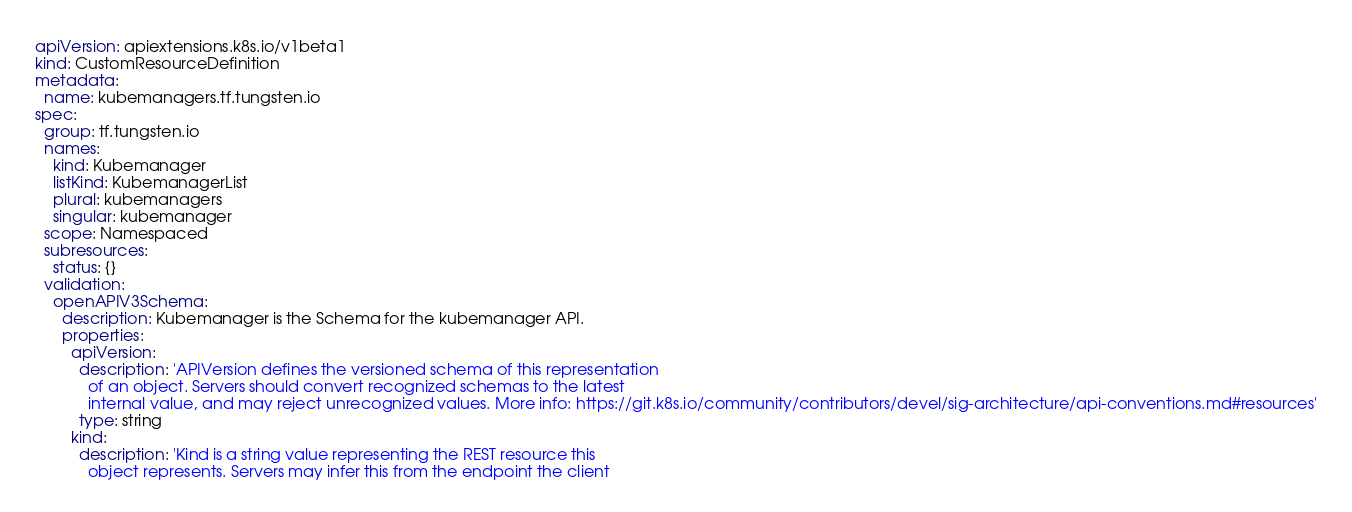<code> <loc_0><loc_0><loc_500><loc_500><_YAML_>apiVersion: apiextensions.k8s.io/v1beta1
kind: CustomResourceDefinition
metadata:
  name: kubemanagers.tf.tungsten.io
spec:
  group: tf.tungsten.io
  names:
    kind: Kubemanager
    listKind: KubemanagerList
    plural: kubemanagers
    singular: kubemanager
  scope: Namespaced
  subresources:
    status: {}
  validation:
    openAPIV3Schema:
      description: Kubemanager is the Schema for the kubemanager API.
      properties:
        apiVersion:
          description: 'APIVersion defines the versioned schema of this representation
            of an object. Servers should convert recognized schemas to the latest
            internal value, and may reject unrecognized values. More info: https://git.k8s.io/community/contributors/devel/sig-architecture/api-conventions.md#resources'
          type: string
        kind:
          description: 'Kind is a string value representing the REST resource this
            object represents. Servers may infer this from the endpoint the client</code> 